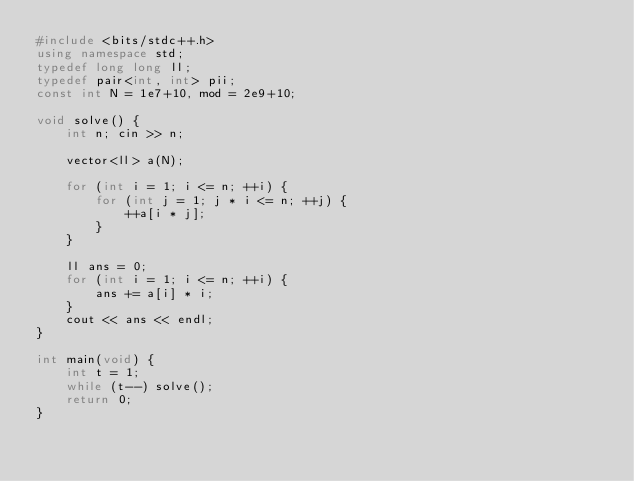<code> <loc_0><loc_0><loc_500><loc_500><_C++_>#include <bits/stdc++.h>
using namespace std;
typedef long long ll;
typedef pair<int, int> pii; 
const int N = 1e7+10, mod = 2e9+10;

void solve() {
    int n; cin >> n;

    vector<ll> a(N);
    
    for (int i = 1; i <= n; ++i) {
        for (int j = 1; j * i <= n; ++j) {
            ++a[i * j];
        }
    }

    ll ans = 0;
    for (int i = 1; i <= n; ++i) {
        ans += a[i] * i;
    }
    cout << ans << endl;
}

int main(void) {
    int t = 1; 
    while (t--) solve();
    return 0;
}</code> 